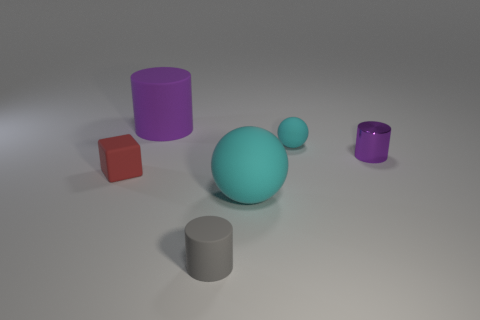Are there any rubber things on the right side of the tiny red rubber cube? On the right side of the tiny red cube, there are no items that can be definitively identified as rubber without additional context or material properties. Visually, there are several geometric objects, including what appears to be a larger teal sphere and various cylinders or cubes of different colors, but their material composition is not discernible from the image alone. 